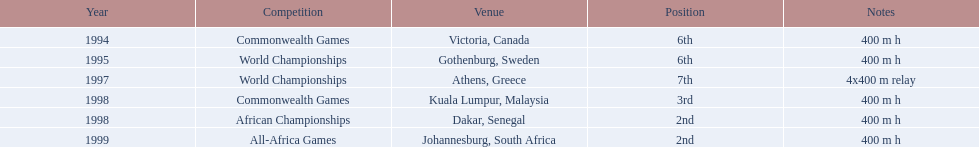In which years did ken harder participate? 1994, 1995, 1997, 1998, 1998, 1999. For the 1997 relay, what length was covered? 4x400 m relay. 